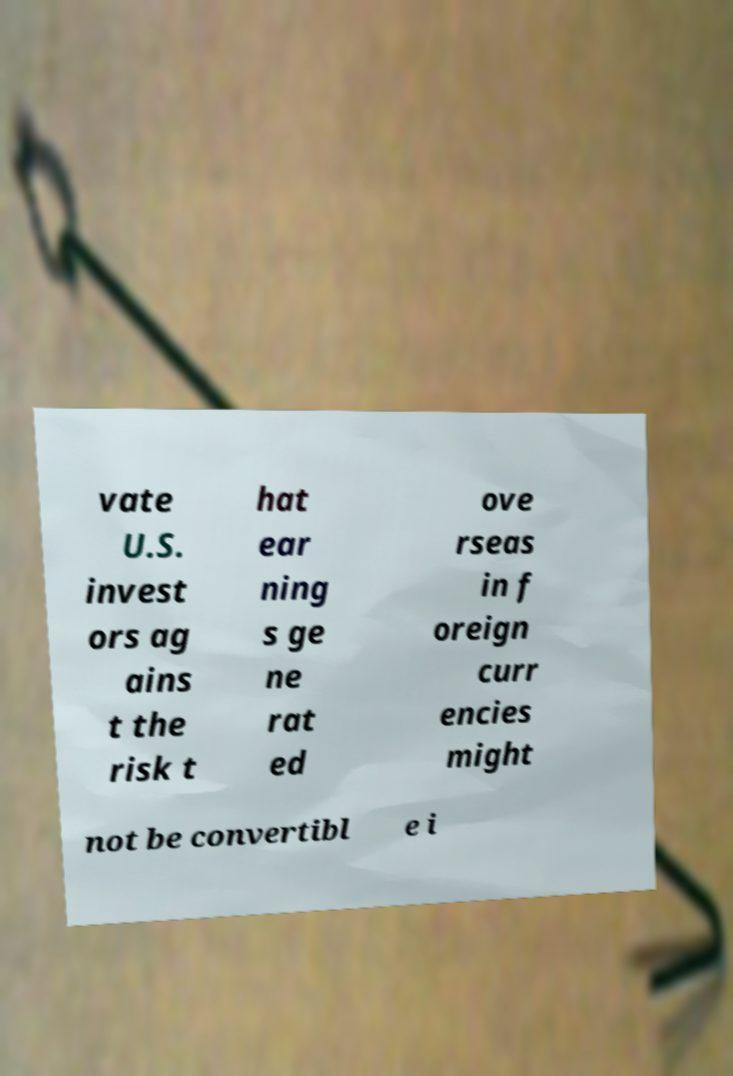Can you read and provide the text displayed in the image?This photo seems to have some interesting text. Can you extract and type it out for me? vate U.S. invest ors ag ains t the risk t hat ear ning s ge ne rat ed ove rseas in f oreign curr encies might not be convertibl e i 